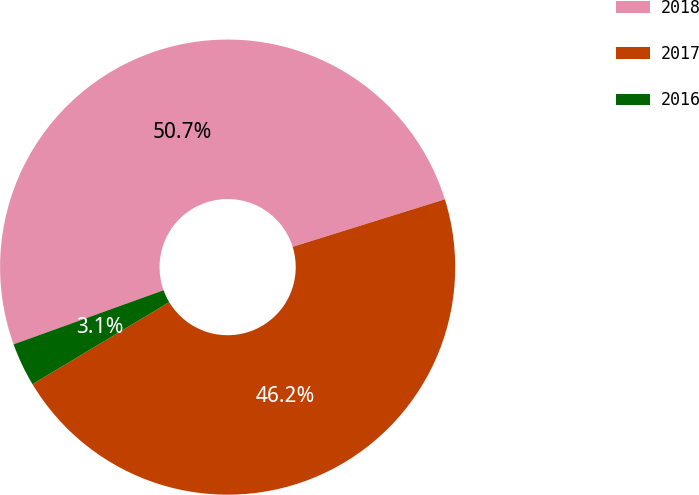Convert chart to OTSL. <chart><loc_0><loc_0><loc_500><loc_500><pie_chart><fcel>2018<fcel>2017<fcel>2016<nl><fcel>50.69%<fcel>46.21%<fcel>3.09%<nl></chart> 